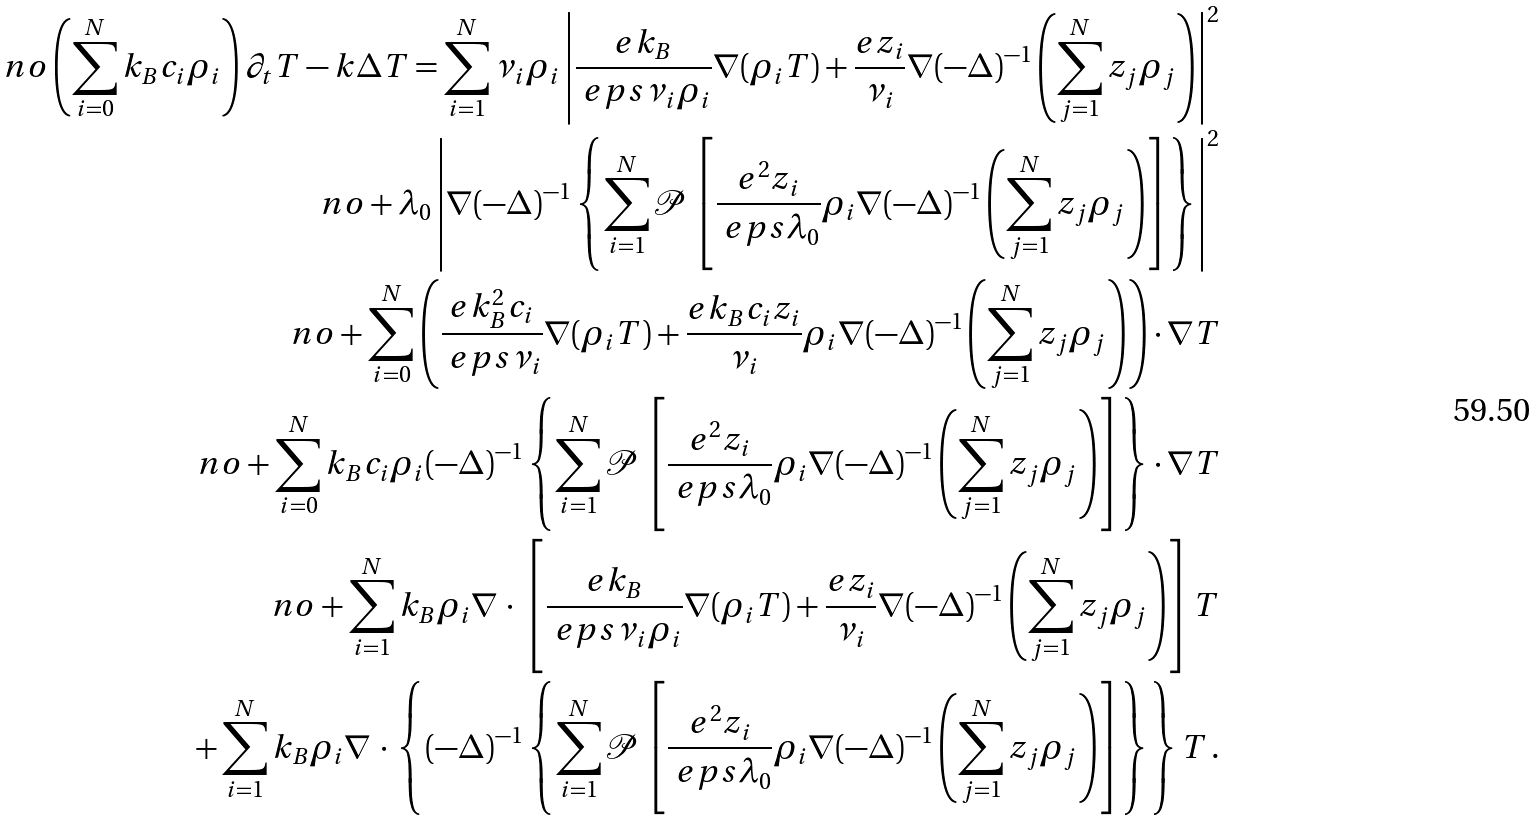<formula> <loc_0><loc_0><loc_500><loc_500>\ n o \left ( \sum _ { i = 0 } ^ { N } k _ { B } c _ { i } \rho _ { i } \right ) \partial _ { t } T - k \Delta T = \sum _ { i = 1 } ^ { N } \nu _ { i } \rho _ { i } \left | \frac { e k _ { B } } { \ e p s \nu _ { i } \rho _ { i } } \nabla ( \rho _ { i } T ) + \frac { e z _ { i } } { \nu _ { i } } \nabla ( - \Delta ) ^ { - 1 } \left ( \sum _ { j = 1 } ^ { N } z _ { j } \rho _ { j } \right ) \right | ^ { 2 } \\ \ n o + \lambda _ { 0 } \left | \nabla ( - \Delta ) ^ { - 1 } \left \{ \sum _ { i = 1 } ^ { N } \mathcal { P } \left [ \frac { e ^ { 2 } z _ { i } } { \ e p s \lambda _ { 0 } } \rho _ { i } \nabla ( - \Delta ) ^ { - 1 } \left ( \sum _ { j = 1 } ^ { N } z _ { j } \rho _ { j } \right ) \right ] \right \} \right | ^ { 2 } \\ \ n o + \sum _ { i = 0 } ^ { N } \left ( \frac { e k _ { B } ^ { 2 } c _ { i } } { \ e p s \nu _ { i } } \nabla ( \rho _ { i } T ) + \frac { e k _ { B } c _ { i } z _ { i } } { \nu _ { i } } \rho _ { i } \nabla ( - \Delta ) ^ { - 1 } \left ( \sum _ { j = 1 } ^ { N } z _ { j } \rho _ { j } \right ) \right ) \cdot \nabla T \\ \ n o + \sum _ { i = 0 } ^ { N } k _ { B } c _ { i } \rho _ { i } ( - \Delta ) ^ { - 1 } \left \{ \sum _ { i = 1 } ^ { N } \mathcal { P } \left [ \frac { e ^ { 2 } z _ { i } } { \ e p s \lambda _ { 0 } } \rho _ { i } \nabla ( - \Delta ) ^ { - 1 } \left ( \sum _ { j = 1 } ^ { N } z _ { j } \rho _ { j } \right ) \right ] \right \} \cdot \nabla T \\ \ n o + \sum _ { i = 1 } ^ { N } k _ { B } \rho _ { i } \nabla \, \cdot \, \left [ \frac { e k _ { B } } { \ e p s \nu _ { i } \rho _ { i } } \nabla ( \rho _ { i } T ) + \frac { e z _ { i } } { \nu _ { i } } \nabla ( - \Delta ) ^ { - 1 } \left ( \sum _ { j = 1 } ^ { N } z _ { j } \rho _ { j } \right ) \right ] T \\ + \sum _ { i = 1 } ^ { N } k _ { B } \rho _ { i } \nabla \, \cdot \, \left \{ ( - \Delta ) ^ { - 1 } \left \{ \sum _ { i = 1 } ^ { N } \mathcal { P } \left [ \frac { e ^ { 2 } z _ { i } } { \ e p s \lambda _ { 0 } } \rho _ { i } \nabla ( - \Delta ) ^ { - 1 } \left ( \sum _ { j = 1 } ^ { N } z _ { j } \rho _ { j } \right ) \right ] \right \} \right \} T \, .</formula> 